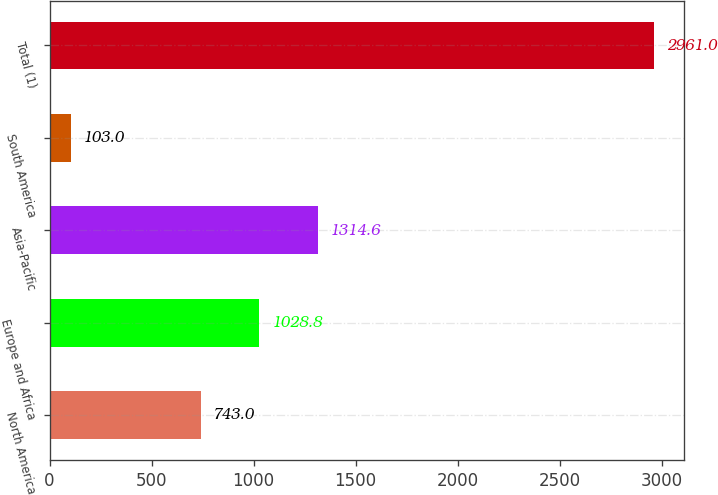<chart> <loc_0><loc_0><loc_500><loc_500><bar_chart><fcel>North America<fcel>Europe and Africa<fcel>Asia-Pacific<fcel>South America<fcel>Total (1)<nl><fcel>743<fcel>1028.8<fcel>1314.6<fcel>103<fcel>2961<nl></chart> 